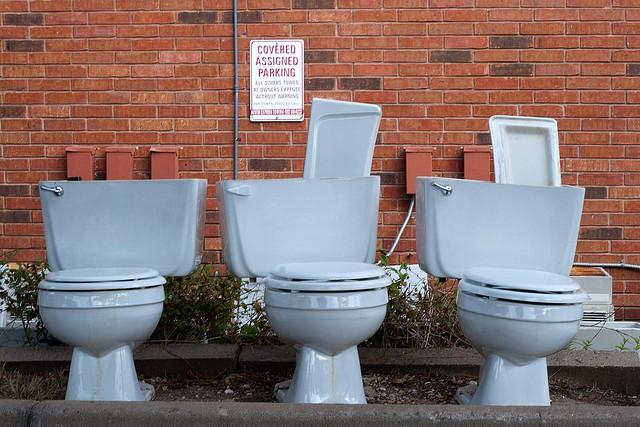How many toilet bowls are sat in this area next to the side of the street?

Choices:
A) one
B) four
C) two
D) three three 